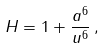<formula> <loc_0><loc_0><loc_500><loc_500>H = 1 + \frac { a ^ { 6 } } { u ^ { 6 } } \, ,</formula> 